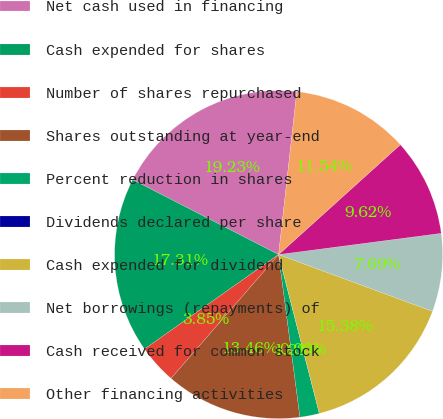Convert chart. <chart><loc_0><loc_0><loc_500><loc_500><pie_chart><fcel>Net cash used in financing<fcel>Cash expended for shares<fcel>Number of shares repurchased<fcel>Shares outstanding at year-end<fcel>Percent reduction in shares<fcel>Dividends declared per share<fcel>Cash expended for dividend<fcel>Net borrowings (repayments) of<fcel>Cash received for common stock<fcel>Other financing activities<nl><fcel>19.23%<fcel>17.31%<fcel>3.85%<fcel>13.46%<fcel>1.92%<fcel>0.0%<fcel>15.38%<fcel>7.69%<fcel>9.62%<fcel>11.54%<nl></chart> 